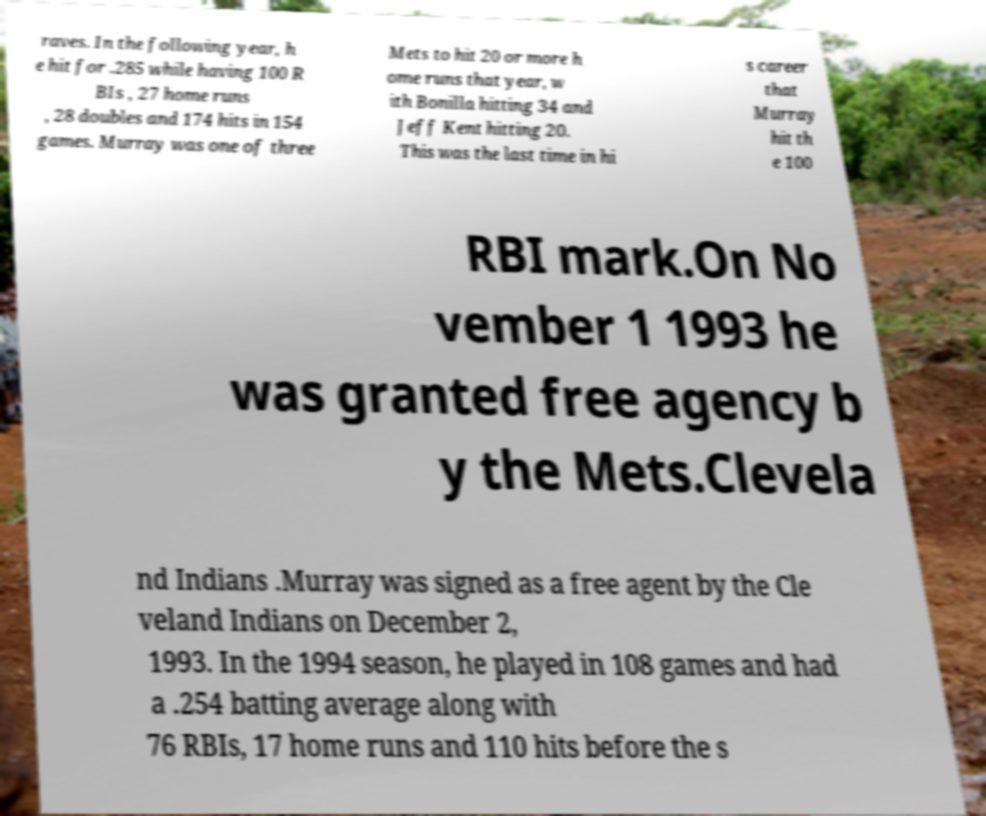For documentation purposes, I need the text within this image transcribed. Could you provide that? raves. In the following year, h e hit for .285 while having 100 R BIs , 27 home runs , 28 doubles and 174 hits in 154 games. Murray was one of three Mets to hit 20 or more h ome runs that year, w ith Bonilla hitting 34 and Jeff Kent hitting 20. This was the last time in hi s career that Murray hit th e 100 RBI mark.On No vember 1 1993 he was granted free agency b y the Mets.Clevela nd Indians .Murray was signed as a free agent by the Cle veland Indians on December 2, 1993. In the 1994 season, he played in 108 games and had a .254 batting average along with 76 RBIs, 17 home runs and 110 hits before the s 